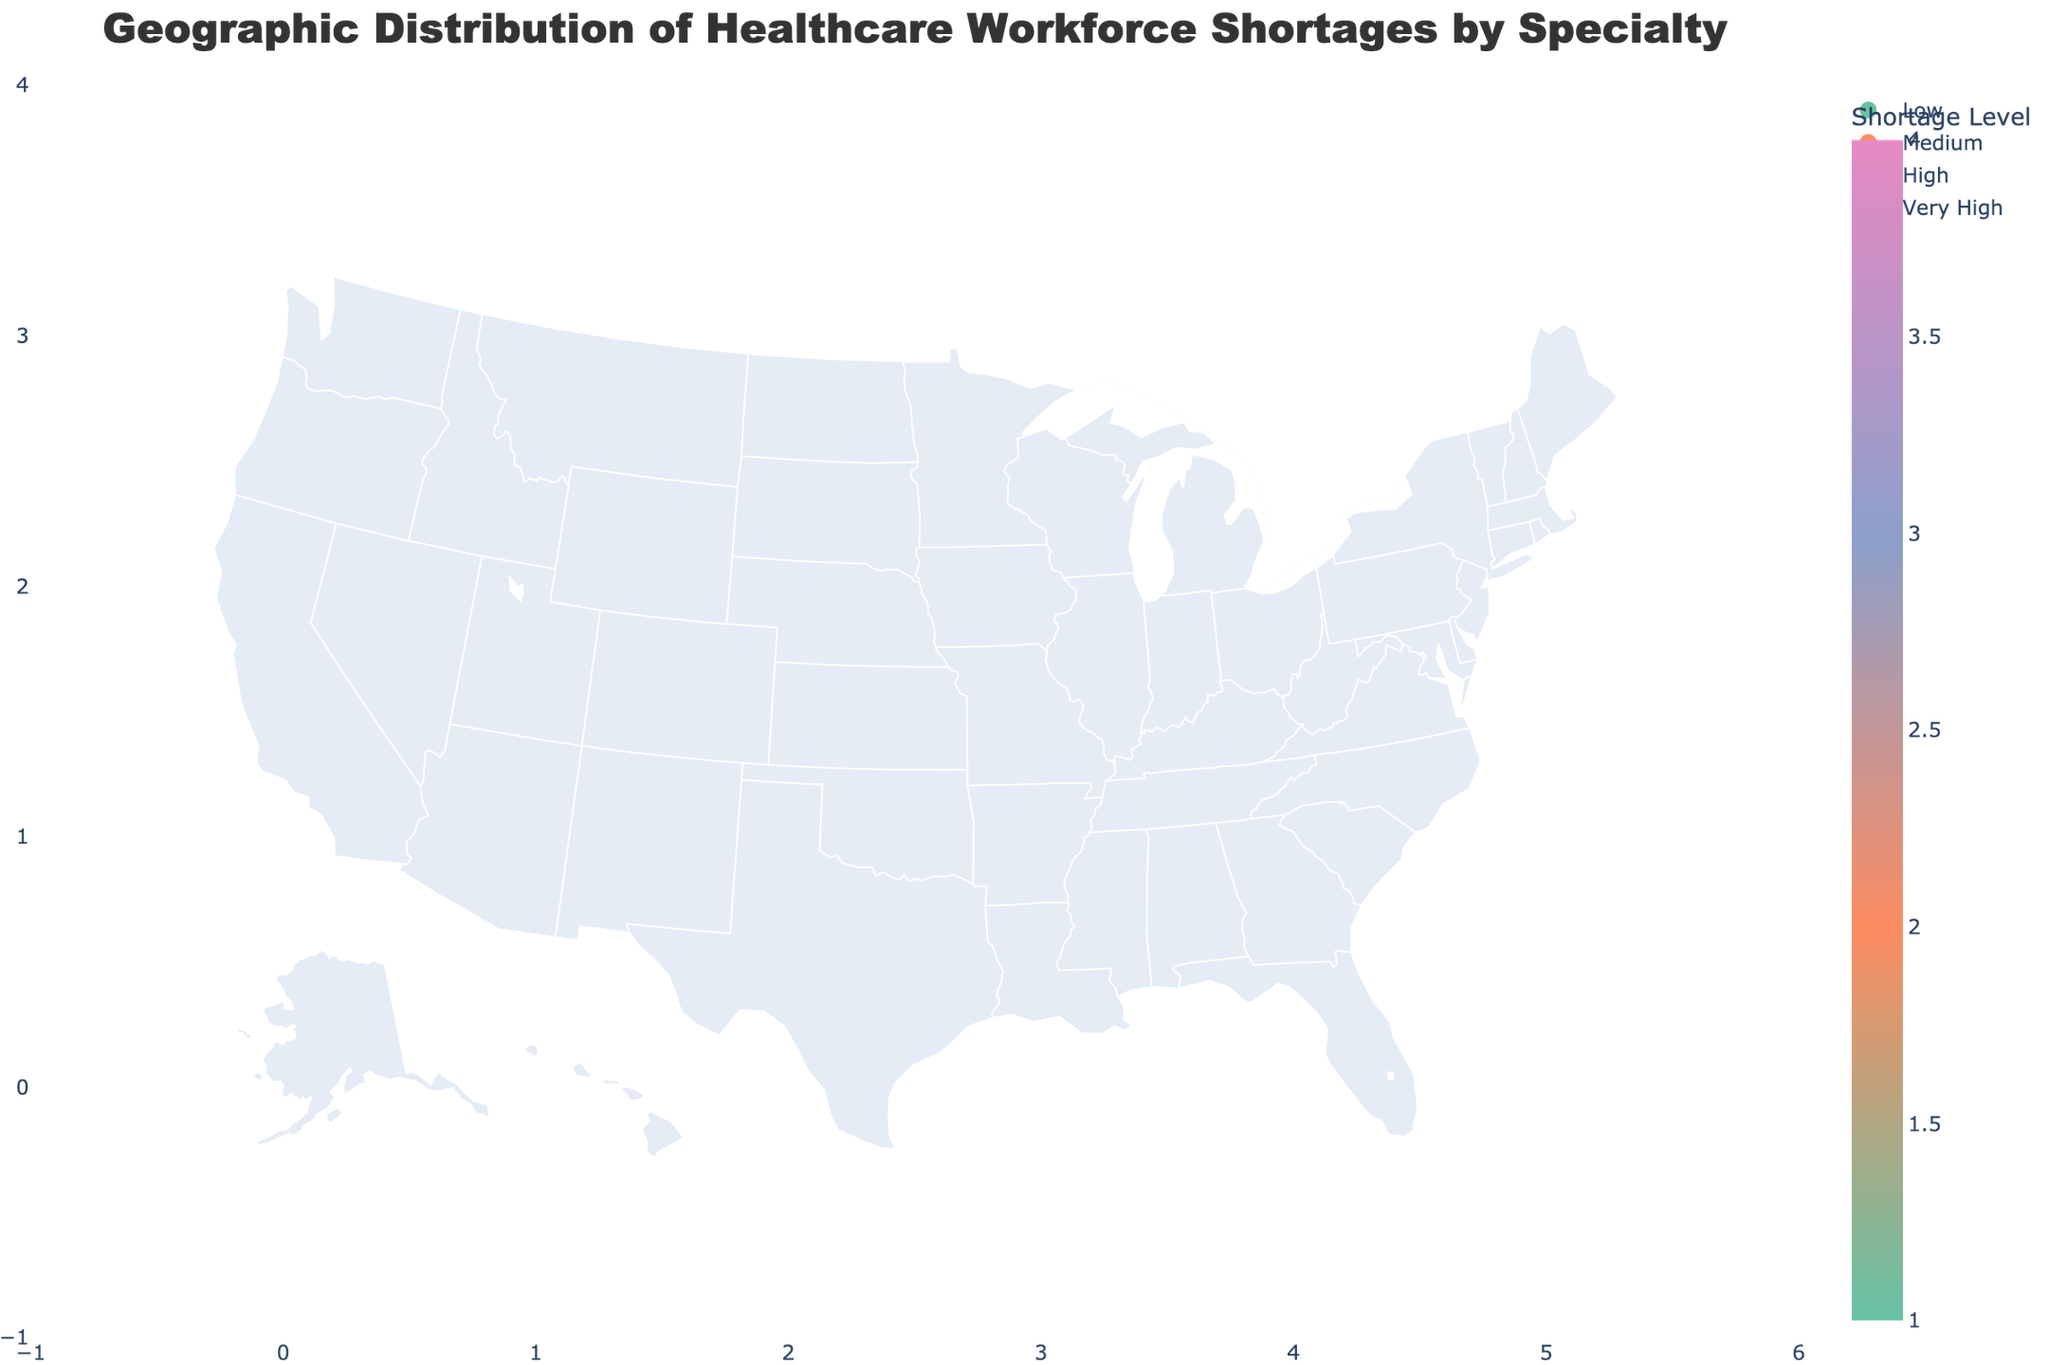What are the states with a 'Very High' shortage level? Identify the states that have been assigned the highest shortage level, which in this case, is 'Very High'.
Answer: Texas and Ohio What specialty in California is experiencing a workforce shortage? Hover over California on the map and read the information associated with it.
Answer: Primary Care Which state has a 'Medium' shortage level for Nursing? Locate 'Medium' shortage levels on the legend, and then identify the state labeled with "Nursing" in the map.
Answer: New York How many states have a 'Low' shortage level? Count the number of states colored in the shade representing 'Low' shortage level according to the custom legend.
Answer: Four What specialties have a 'High' shortage level and in which states? Find the states colored in shades representing 'High' shortage from the map and identify the specialties mentioned.
Answer: California (Primary Care), Pennsylvania (Pediatrics), Michigan (Neurology), Arizona (Orthopedics), Indiana (Pulmonology), Minnesota (Endocrinology) Which state has a 'Very High' shortage level for Mental Health? Hover over the state with the 'Very High' shortage level color and locate the specialty 'Mental Health'.
Answer: Texas Between Illinois and Virginia, which state has a higher shortage level and for which specialties? Compare the colors and shortage levels of Illinois and Virginia, then identify the corresponding specialties.
Answer: Illinois (Emergency Medicine) has a higher shortage level than Virginia (Obstetrics) Which states have a 'Medium' shortage level, and what are their specialties? Identify all states colored with 'Medium' shortage level from the custom legend and hover to find their specialties.
Answer: New York (Nursing), Illinois (Emergency Medicine), Georgia (Oncology), Virginia (Obstetrics), Massachusetts (Radiology), Colorado (Dermatology), Missouri (Gastroenterology) What specialty is experiencing a workforce shortage in Minnesota, and what is the shortage level? Hover over Minnesota on the map to find out the specialty and shortage level.
Answer: Endocrinology, High How many states have 'High' or 'Very High' shortage levels combined? Count the number of states from the map colored in shades representing either 'High' or 'Very High' levels.
Answer: Nine 